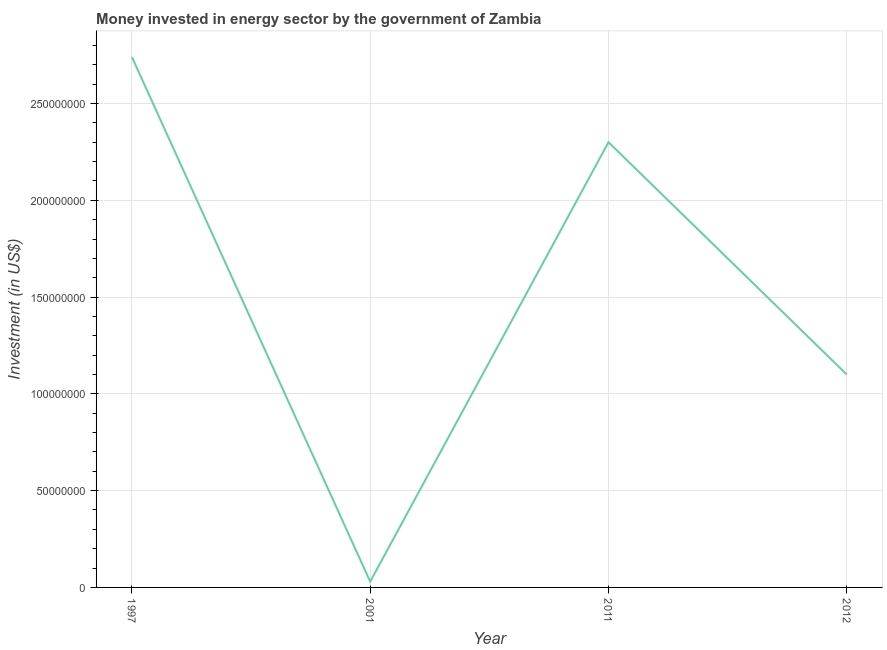What is the investment in energy in 2001?
Your answer should be very brief. 3.00e+06. Across all years, what is the maximum investment in energy?
Offer a terse response. 2.74e+08. Across all years, what is the minimum investment in energy?
Your response must be concise. 3.00e+06. In which year was the investment in energy minimum?
Provide a succinct answer. 2001. What is the sum of the investment in energy?
Keep it short and to the point. 6.17e+08. What is the difference between the investment in energy in 1997 and 2012?
Your answer should be very brief. 1.64e+08. What is the average investment in energy per year?
Your response must be concise. 1.54e+08. What is the median investment in energy?
Your answer should be compact. 1.70e+08. In how many years, is the investment in energy greater than 150000000 US$?
Offer a very short reply. 2. What is the ratio of the investment in energy in 2001 to that in 2012?
Your response must be concise. 0.03. What is the difference between the highest and the second highest investment in energy?
Make the answer very short. 4.40e+07. Is the sum of the investment in energy in 2001 and 2012 greater than the maximum investment in energy across all years?
Provide a succinct answer. No. What is the difference between the highest and the lowest investment in energy?
Your response must be concise. 2.71e+08. How many years are there in the graph?
Offer a very short reply. 4. Are the values on the major ticks of Y-axis written in scientific E-notation?
Give a very brief answer. No. Does the graph contain grids?
Keep it short and to the point. Yes. What is the title of the graph?
Your answer should be compact. Money invested in energy sector by the government of Zambia. What is the label or title of the X-axis?
Provide a succinct answer. Year. What is the label or title of the Y-axis?
Your answer should be very brief. Investment (in US$). What is the Investment (in US$) in 1997?
Give a very brief answer. 2.74e+08. What is the Investment (in US$) in 2001?
Offer a terse response. 3.00e+06. What is the Investment (in US$) in 2011?
Offer a terse response. 2.30e+08. What is the Investment (in US$) of 2012?
Your answer should be very brief. 1.10e+08. What is the difference between the Investment (in US$) in 1997 and 2001?
Give a very brief answer. 2.71e+08. What is the difference between the Investment (in US$) in 1997 and 2011?
Provide a succinct answer. 4.40e+07. What is the difference between the Investment (in US$) in 1997 and 2012?
Your answer should be very brief. 1.64e+08. What is the difference between the Investment (in US$) in 2001 and 2011?
Ensure brevity in your answer.  -2.27e+08. What is the difference between the Investment (in US$) in 2001 and 2012?
Give a very brief answer. -1.07e+08. What is the difference between the Investment (in US$) in 2011 and 2012?
Keep it short and to the point. 1.20e+08. What is the ratio of the Investment (in US$) in 1997 to that in 2001?
Your answer should be very brief. 91.33. What is the ratio of the Investment (in US$) in 1997 to that in 2011?
Your answer should be compact. 1.19. What is the ratio of the Investment (in US$) in 1997 to that in 2012?
Offer a very short reply. 2.49. What is the ratio of the Investment (in US$) in 2001 to that in 2011?
Your answer should be very brief. 0.01. What is the ratio of the Investment (in US$) in 2001 to that in 2012?
Your answer should be compact. 0.03. What is the ratio of the Investment (in US$) in 2011 to that in 2012?
Keep it short and to the point. 2.09. 